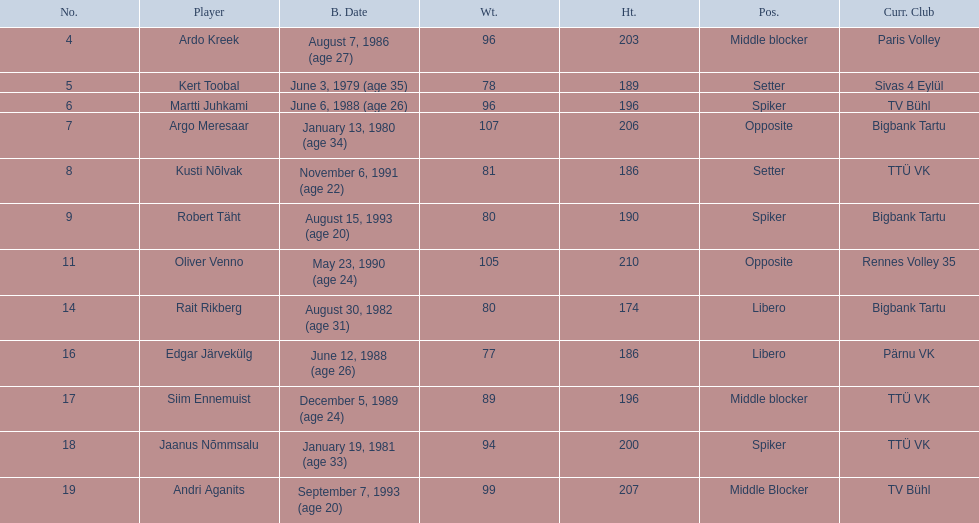What are the heights in cm of the men on the team? 203, 189, 196, 206, 186, 190, 210, 174, 186, 196, 200, 207. What is the tallest height of a team member? 210. Which player stands at 210? Oliver Venno. 